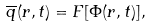Convert formula to latex. <formula><loc_0><loc_0><loc_500><loc_500>\overline { q } ( { r } , t ) = F [ \Phi ( { r } , t ) ] ,</formula> 